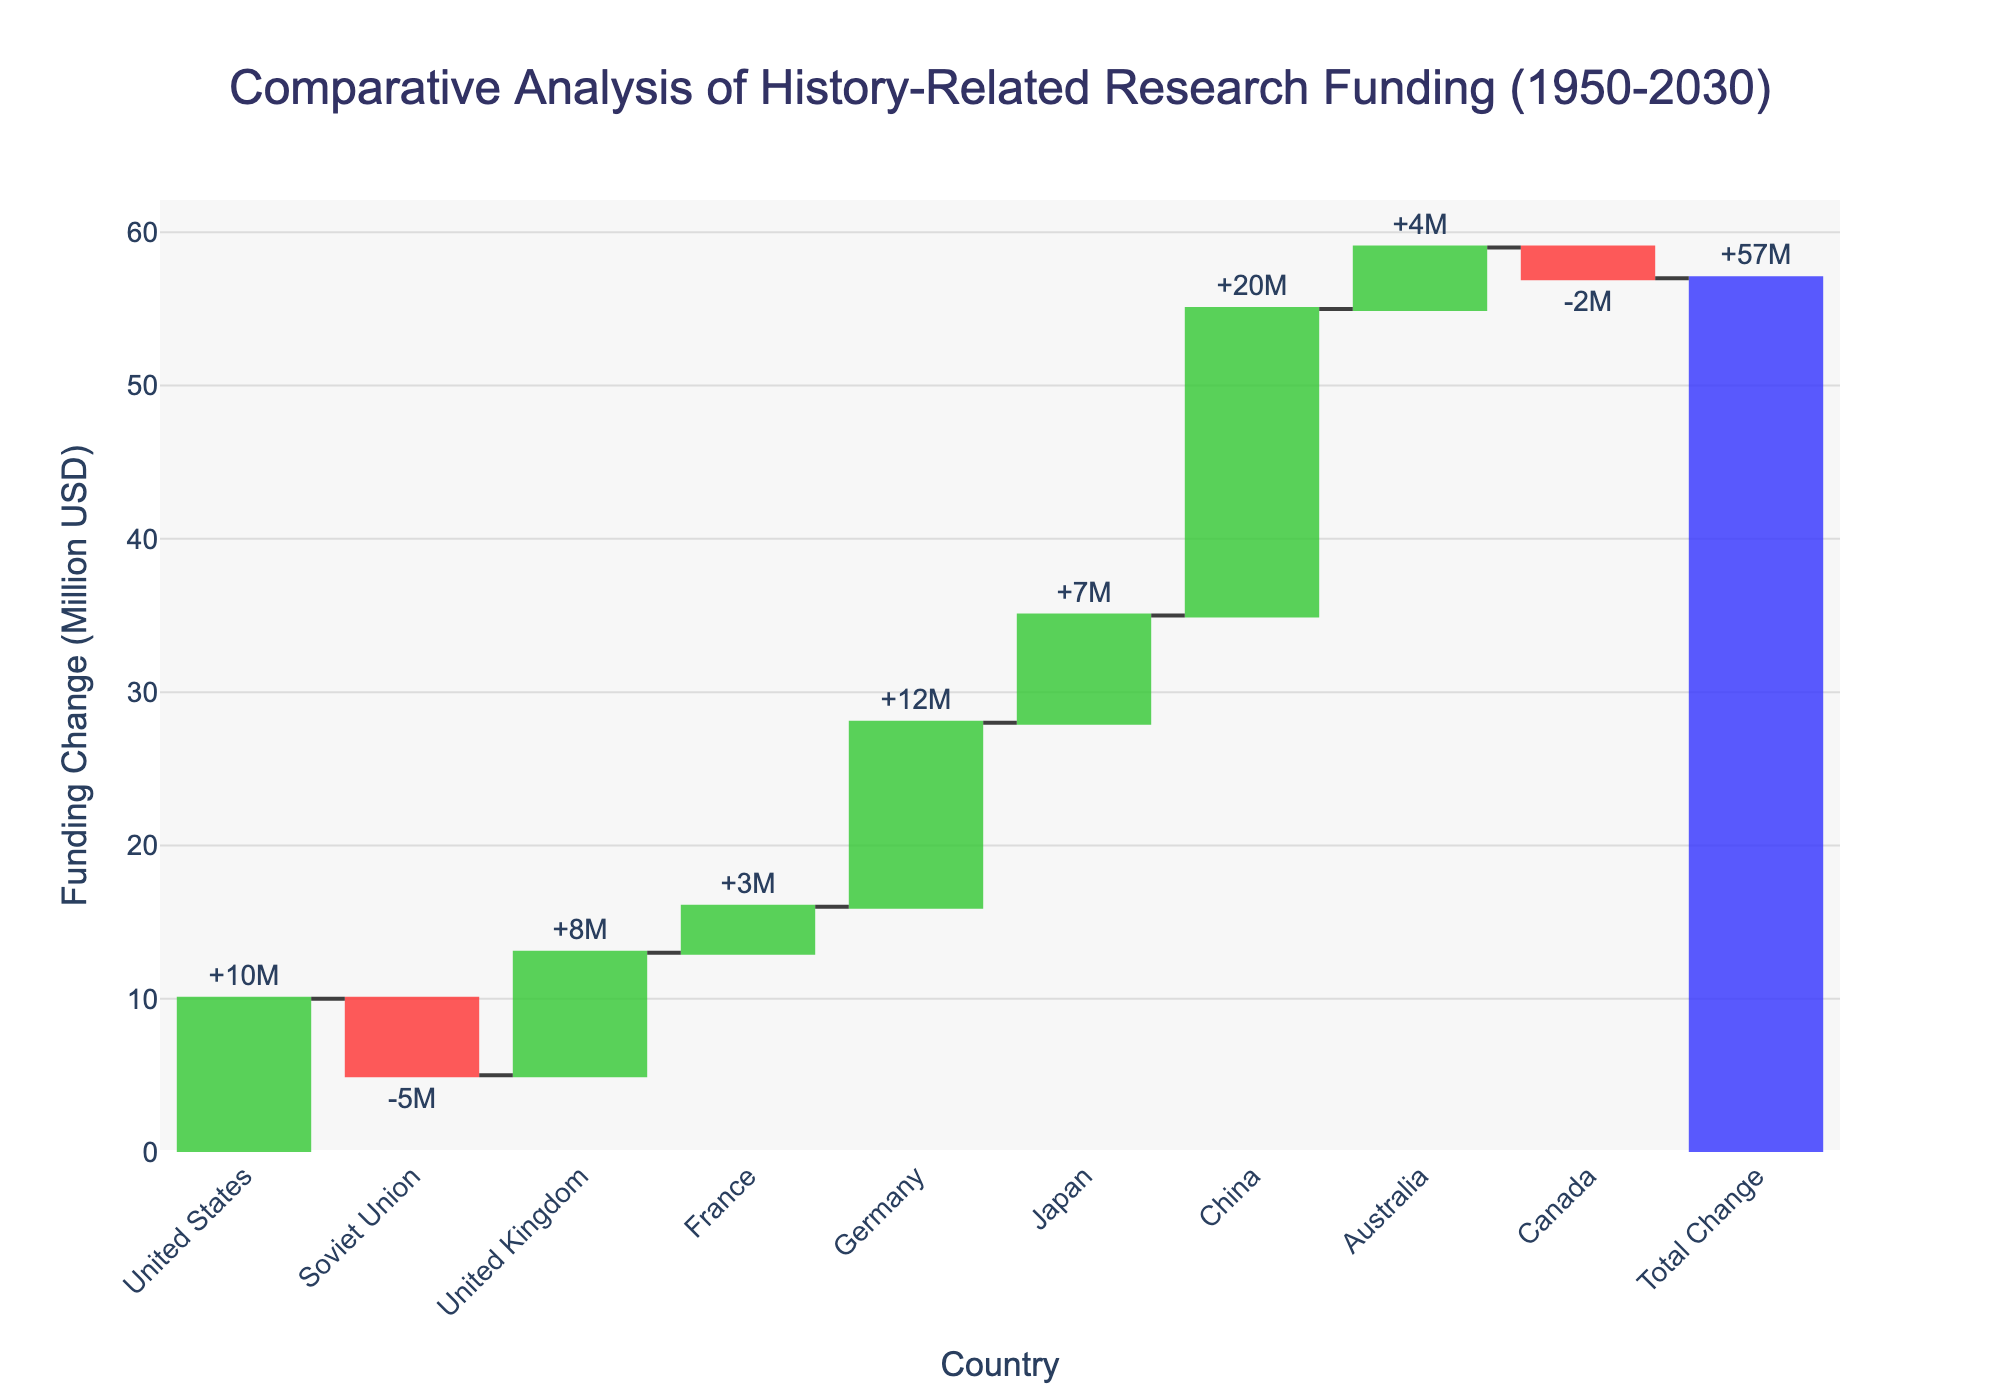what is the title of the chart? The title is located at the top center of the chart. It provides a brief summary of the data being represented.
Answer: Comparative Analysis of History-Related Research Funding (1950-2030) what is the total funding change? The total funding change is depicted in the chart as the final bar in the waterfall. It represents the summation of all individual funding changes.
Answer: 57 million USD which country had the largest increase in funding? By observing the height and color of the bars, the country with the tallest green bar indicates the largest increase in funding.
Answer: China which country had the largest decrease in funding? By observing the height and color of the bars, the country with the tallest red bar indicates the largest decrease in funding.
Answer: Soviet Union what was the funding change for Germany in 1990? Locate the bar labeled "Germany" and refer to the corresponding funding change value displayed.
Answer: 12 million USD what is the average funding change from 1950 to 2020? Sum the individual funding changes from 1950 to 2020 and divide by the number of data points within this range.
Answer: (10 - 5 + 8 + 3 + 12 + 7 + 20 + 4) / 8 = 59/8 = 7.375 million USD which country contributed the least to the total funding change after 1950? Comparing the heights of the individual bars post-1950, the smallest (red or green) bar reflects the least contribution to the total funding change.
Answer: Canada how much did the funding change from the United States to the Soviet Union? The difference in funding changes between the United States (1950) and the Soviet Union (1960) is calculated.
Answer: 10 - (-5) = 15 million USD how many countries had a positive funding change? Count the green bars representing positive funding changes over the years.
Answer: 6 countries 